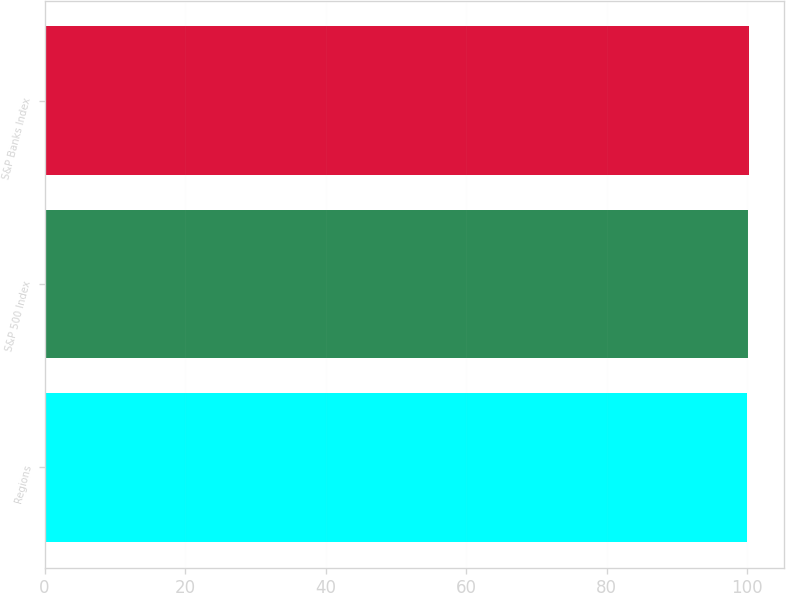Convert chart. <chart><loc_0><loc_0><loc_500><loc_500><bar_chart><fcel>Regions<fcel>S&P 500 Index<fcel>S&P Banks Index<nl><fcel>100<fcel>100.1<fcel>100.2<nl></chart> 